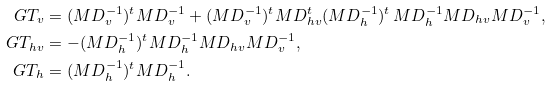<formula> <loc_0><loc_0><loc_500><loc_500>\ G T _ { v } & = ( \L M D _ { v } ^ { - 1 } ) ^ { t } \L M D _ { v } ^ { - 1 } + ( \L M D _ { v } ^ { - 1 } ) ^ { t } \L M D _ { h v } ^ { t } ( \L M D _ { h } ^ { - 1 } ) ^ { t } \, \L M D _ { h } ^ { - 1 } \L M D _ { h v } \L M D _ { v } ^ { - 1 } , \\ \ G T _ { h v } & = - ( \L M D _ { h } ^ { - 1 } ) ^ { t } \L M D _ { h } ^ { - 1 } \L M D _ { h v } \L M D _ { v } ^ { - 1 } , \\ \ G T _ { h } & = ( \L M D _ { h } ^ { - 1 } ) ^ { t } \L M D _ { h } ^ { - 1 } .</formula> 